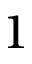<formula> <loc_0><loc_0><loc_500><loc_500>1</formula> 